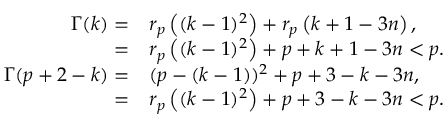Convert formula to latex. <formula><loc_0><loc_0><loc_500><loc_500>\begin{array} { r l } { \Gamma ( k ) = } & { r _ { p } \left ( ( k - 1 ) ^ { 2 } \right ) + r _ { p } \left ( k + 1 - 3 n \right ) , } \\ { = } & { r _ { p } \left ( ( k - 1 ) ^ { 2 } \right ) + p + k + 1 - 3 n < p . } \\ { \Gamma ( p + 2 - k ) = } & { \ r { ( p - ( k - 1 ) ) ^ { 2 } } + \ r { p + 3 - k - 3 n } , } \\ { = } & { r _ { p } \left ( ( k - 1 ) ^ { 2 } \right ) + p + 3 - k - 3 n < p . } \end{array}</formula> 